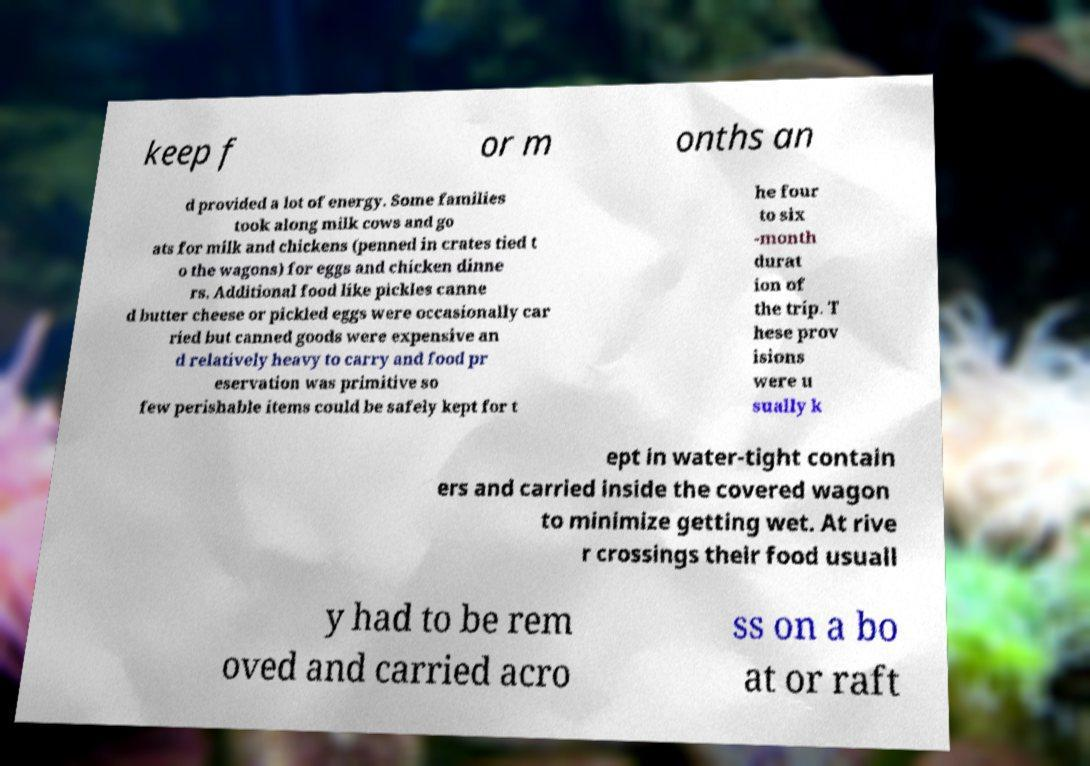There's text embedded in this image that I need extracted. Can you transcribe it verbatim? keep f or m onths an d provided a lot of energy. Some families took along milk cows and go ats for milk and chickens (penned in crates tied t o the wagons) for eggs and chicken dinne rs. Additional food like pickles canne d butter cheese or pickled eggs were occasionally car ried but canned goods were expensive an d relatively heavy to carry and food pr eservation was primitive so few perishable items could be safely kept for t he four to six -month durat ion of the trip. T hese prov isions were u sually k ept in water-tight contain ers and carried inside the covered wagon to minimize getting wet. At rive r crossings their food usuall y had to be rem oved and carried acro ss on a bo at or raft 